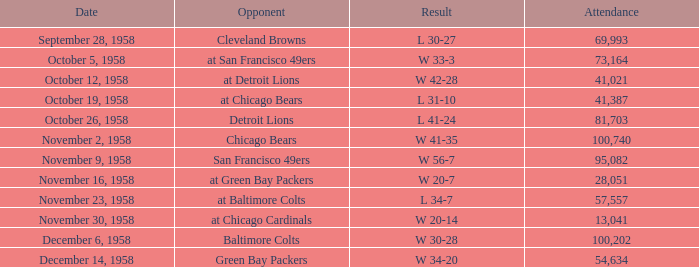What was the higest attendance on November 9, 1958? 95082.0. 